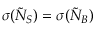<formula> <loc_0><loc_0><loc_500><loc_500>\sigma ( \tilde { N } _ { S } ) = \sigma ( \tilde { N } _ { B } )</formula> 